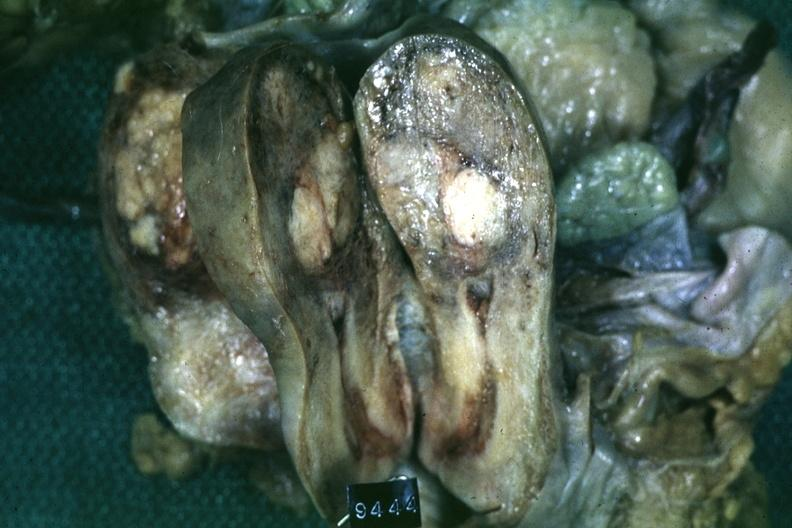what is present?
Answer the question using a single word or phrase. Female reproductive 